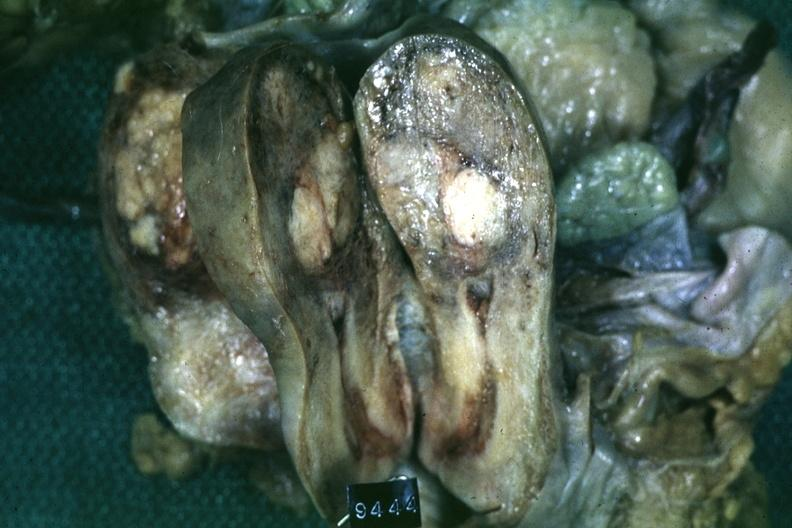what is present?
Answer the question using a single word or phrase. Female reproductive 